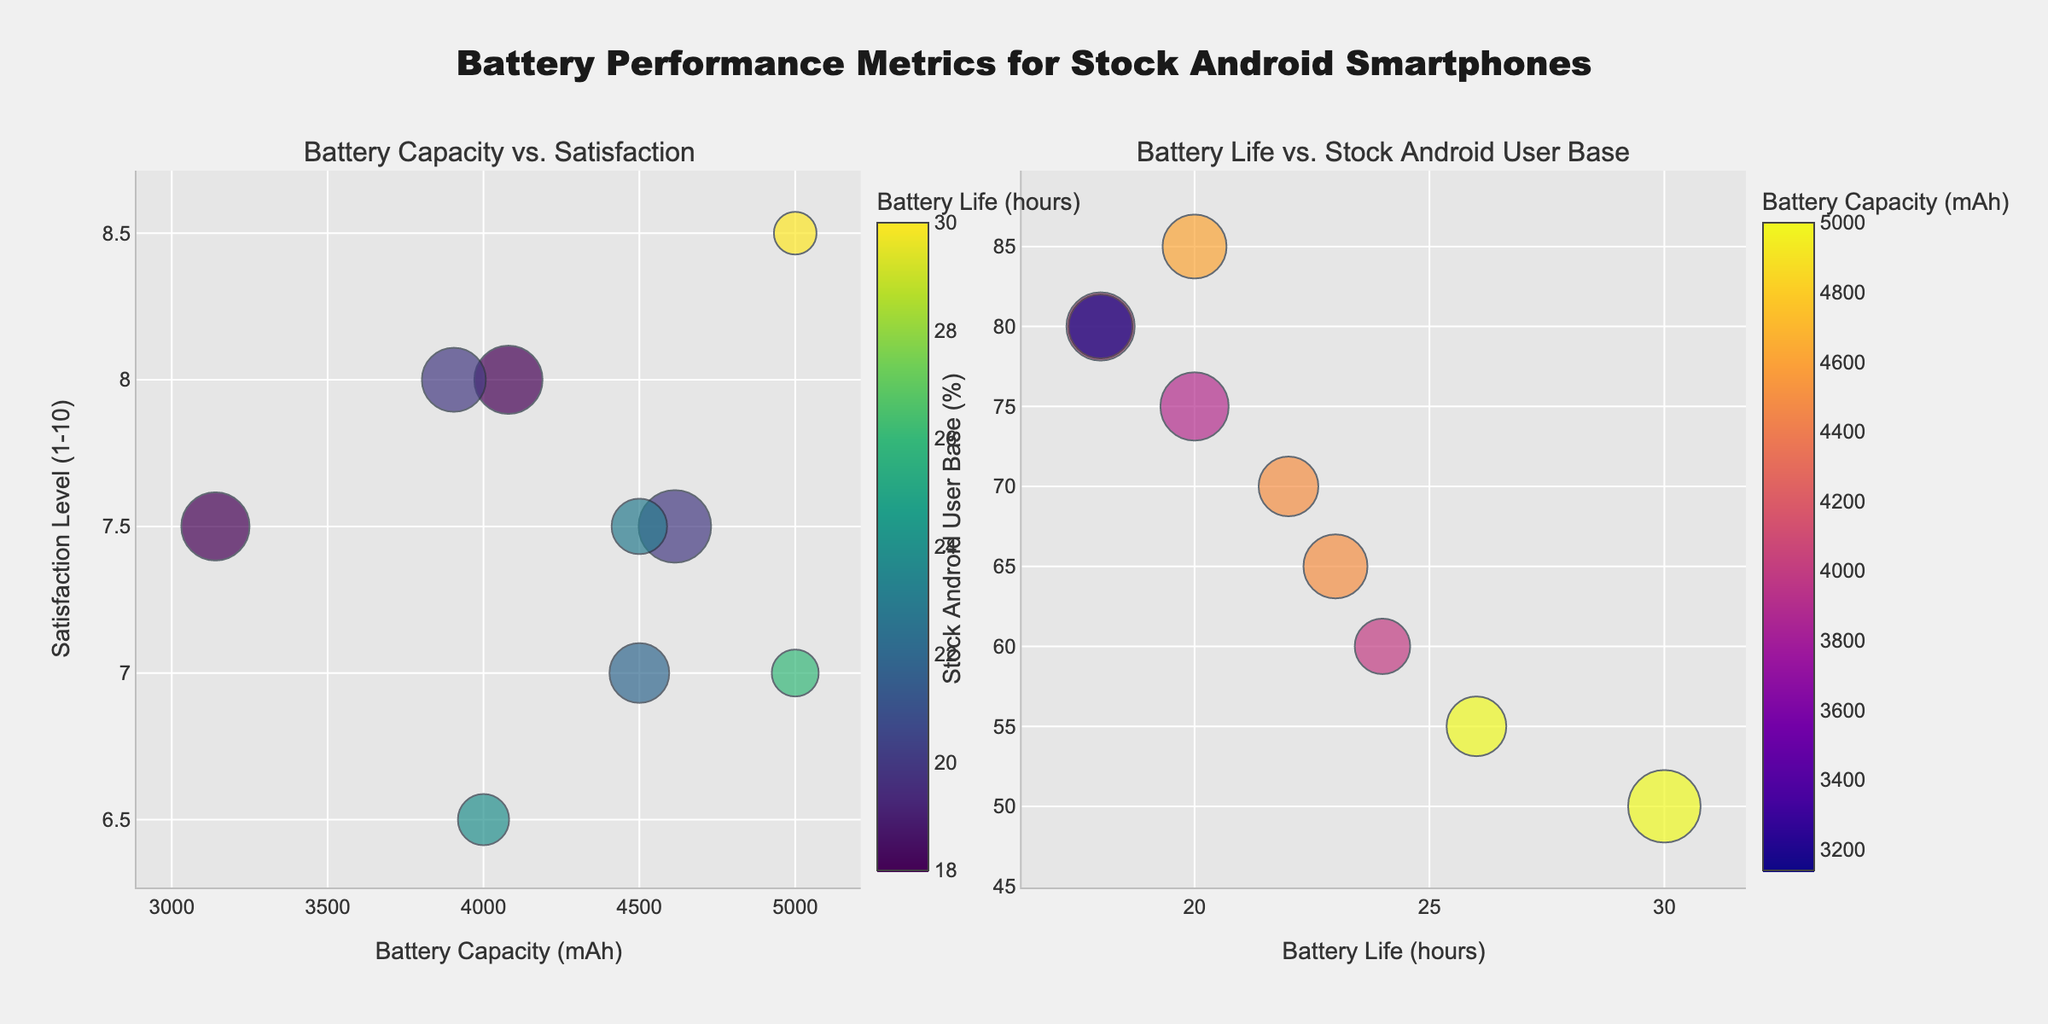What is the title of the figure? The title is displayed at the top and reads "Battery Performance Metrics for Stock Android Smartphones".
Answer: Battery Performance Metrics for Stock Android Smartphones How many data points are there in the first subplot? Count the number of markers present in the scatter plot on the first subplot. There are 9 markers, hence 9 data points.
Answer: 9 Which smartphone has the highest battery life satisfaction level? Look for the marker with the highest y-value in the first subplot representing satisfaction levels. The marker at the highest point (y=8.5) is for the Motorola Moto G Power (2021).
Answer: Motorola Moto G Power (2021) What color represents the highest battery life in the first subplot? Examine the color scale for battery life (hours) on the first subplot. The highest value (30 hours) corresponds to the lightest color on the Viridis color scale.
Answer: Lightest color on the Viridis scale Which smartphone has the highest stock Android user base? In the second subplot, find the marker with the highest y-value representing the stock Android user base. The marker with the highest y-value (85%) is for Google Pixel 6.
Answer: Google Pixel 6 Is there a smartphone model that appears close to the top right corner in both subplots? In both subplots, look for a marker near the top right corner. The Google Pixel 6 appears close to the top right in both plots.
Answer: Google Pixel 6 Among smartphones with a satisfaction level of 7.5, which one has the largest battery capacity? Look in the first subplot for markers at y=7.5. The Google Pixel 6 (x=4614) and Sony Xperia 5 III (x=4500) are at this level. The Google Pixel 6 has the largest battery capacity.
Answer: Google Pixel 6 What is the relationship between battery capacity and battery life satisfaction in the first subplot? Observe the overall trend in the first subplot. There seems to be no clear linear relationship, as varying capacities have similar satisfaction levels.
Answer: No clear relationship Which smartphone has the highest battery life compared to its battery capacity? In the first subplot, find the highest battery life marker and correlate it with the x-axis value for battery capacity. The Motorola Moto G Power (2021) has the highest battery life (30 hours) for a 5000 mAh battery capacity.
Answer: Motorola Moto G Power (2021) Do stock Android users prefer higher battery capacity or longer battery life? Examine both subplots: one focusing on battery capacity vs. satisfaction and the other on battery life vs. stock Android user base. Both high battery capacity and long battery life are valued by stock Android users but preferences seem mixed without a clear trend favoring one over the other.
Answer: Mixed preferences 